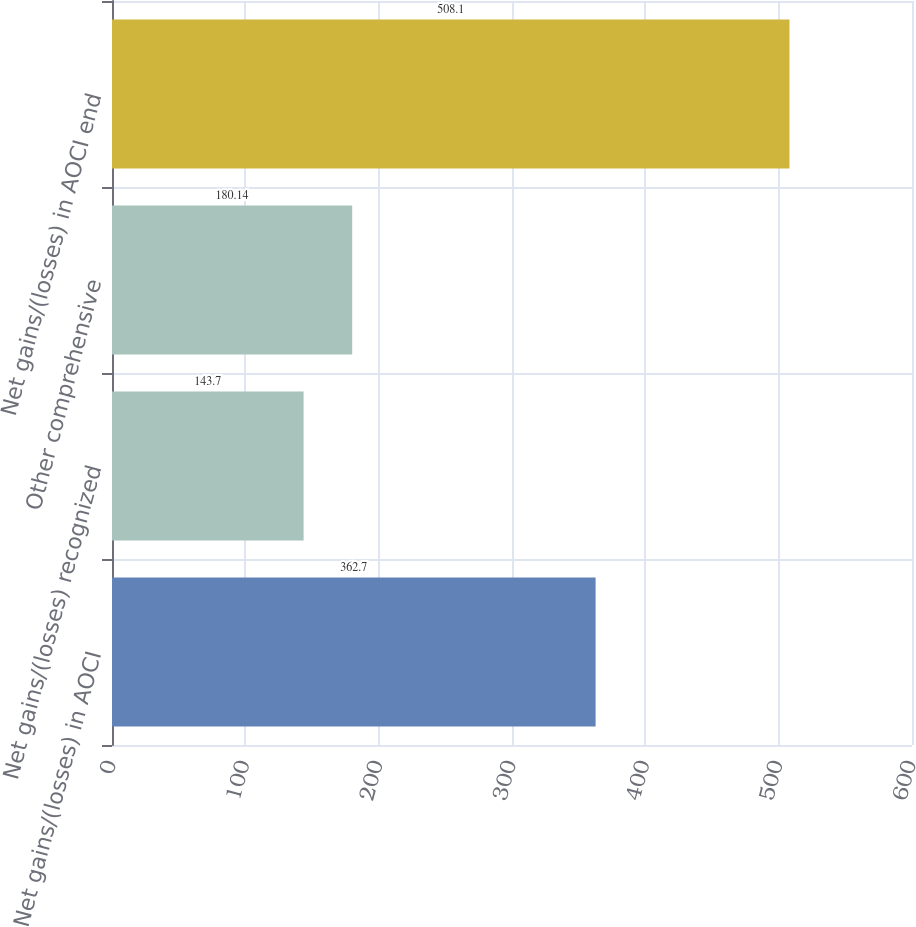Convert chart. <chart><loc_0><loc_0><loc_500><loc_500><bar_chart><fcel>Net gains/(losses) in AOCI<fcel>Net gains/(losses) recognized<fcel>Other comprehensive<fcel>Net gains/(losses) in AOCI end<nl><fcel>362.7<fcel>143.7<fcel>180.14<fcel>508.1<nl></chart> 